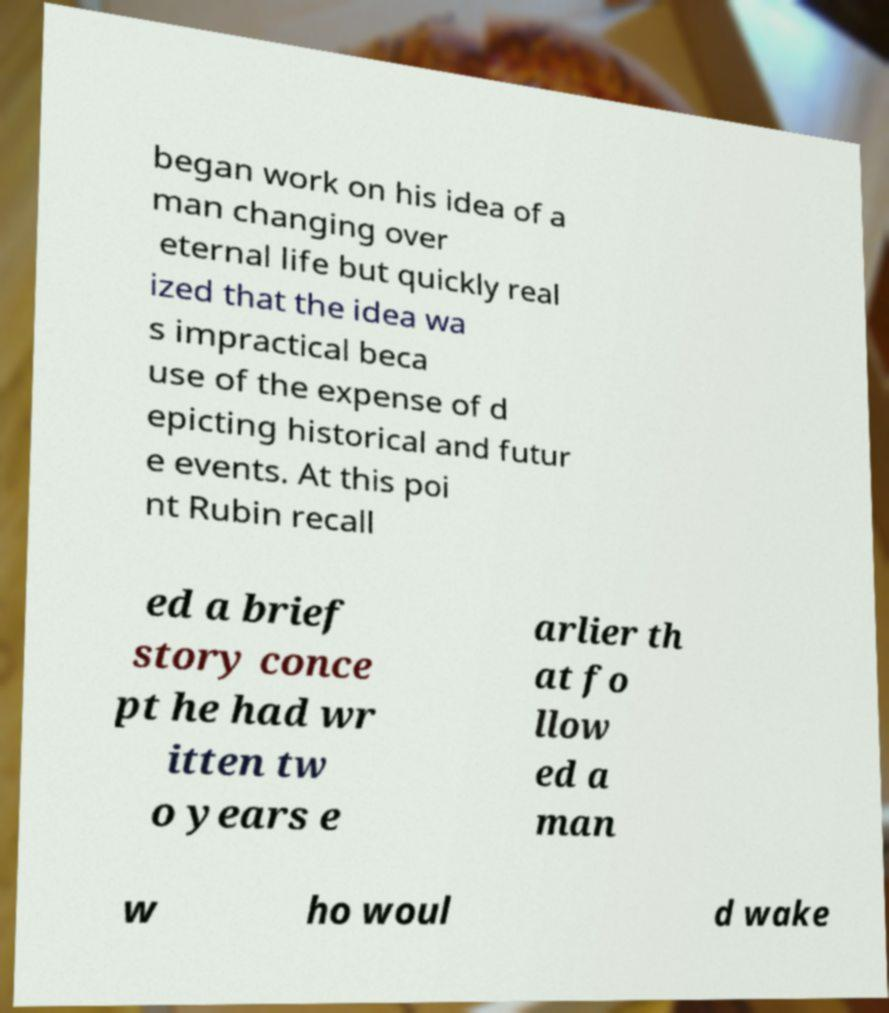What messages or text are displayed in this image? I need them in a readable, typed format. began work on his idea of a man changing over eternal life but quickly real ized that the idea wa s impractical beca use of the expense of d epicting historical and futur e events. At this poi nt Rubin recall ed a brief story conce pt he had wr itten tw o years e arlier th at fo llow ed a man w ho woul d wake 